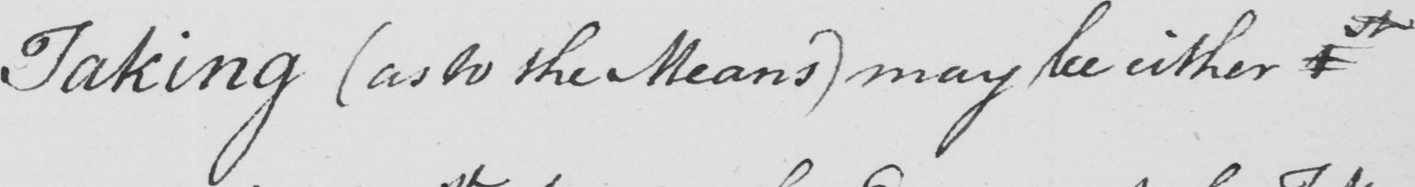What is written in this line of handwriting? Taking  ( as to the Means )  may be either 1st 